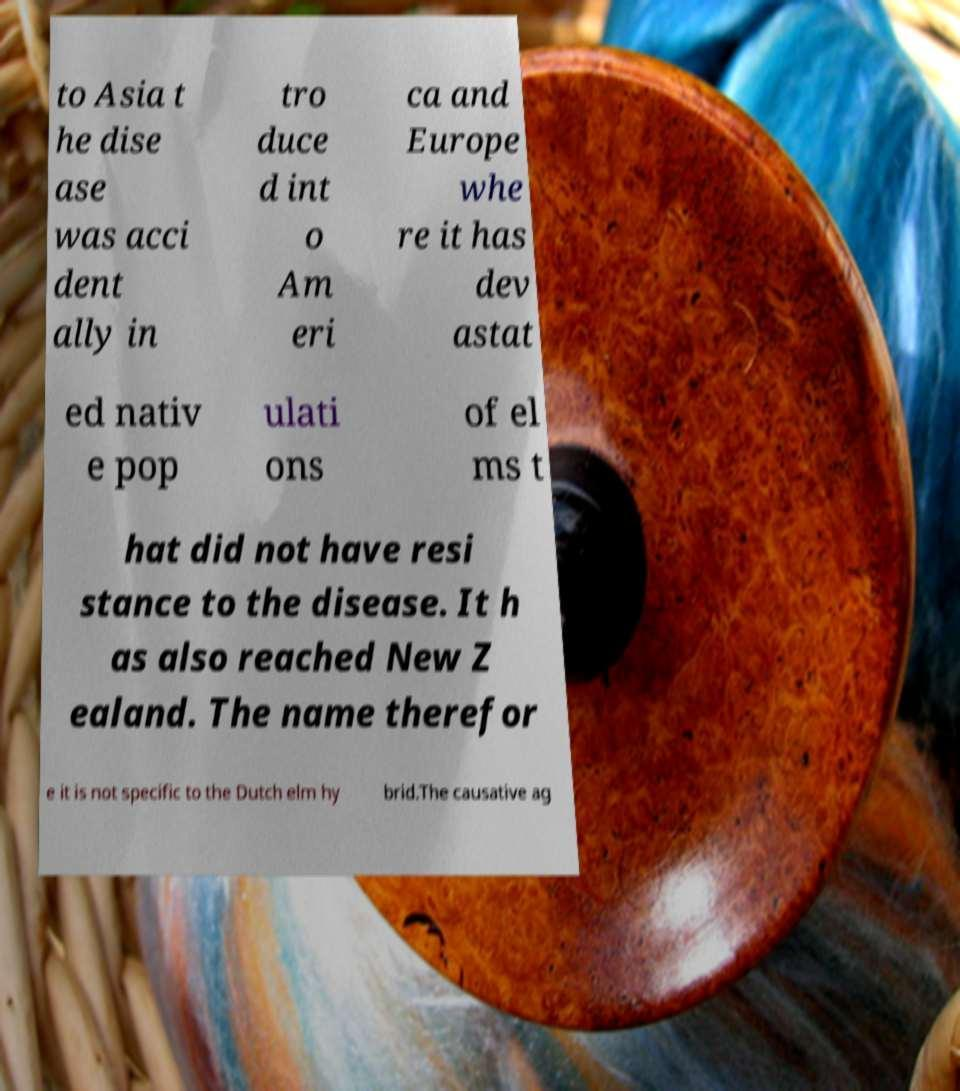Can you accurately transcribe the text from the provided image for me? to Asia t he dise ase was acci dent ally in tro duce d int o Am eri ca and Europe whe re it has dev astat ed nativ e pop ulati ons of el ms t hat did not have resi stance to the disease. It h as also reached New Z ealand. The name therefor e it is not specific to the Dutch elm hy brid.The causative ag 